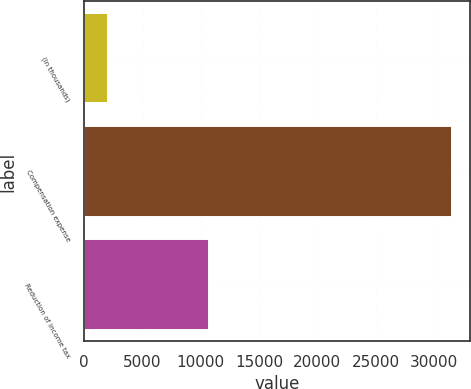<chart> <loc_0><loc_0><loc_500><loc_500><bar_chart><fcel>(In thousands)<fcel>Compensation expense<fcel>Reduction of income tax<nl><fcel>2012<fcel>31533<fcel>10724<nl></chart> 